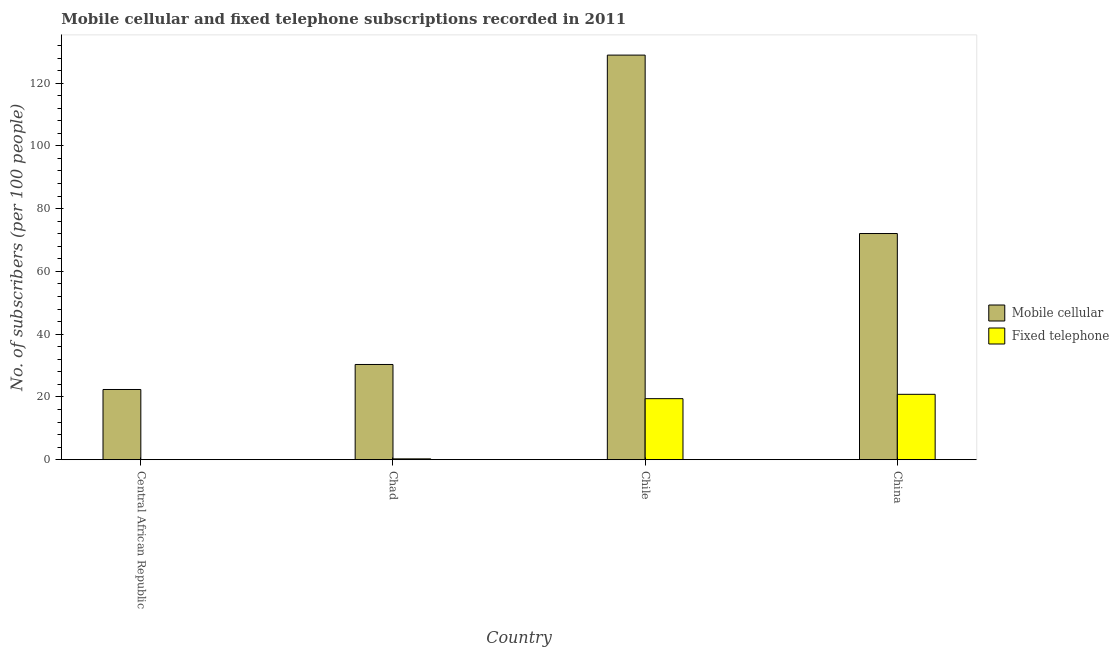Are the number of bars on each tick of the X-axis equal?
Offer a very short reply. Yes. In how many cases, is the number of bars for a given country not equal to the number of legend labels?
Make the answer very short. 0. What is the number of fixed telephone subscribers in Chad?
Make the answer very short. 0.26. Across all countries, what is the maximum number of mobile cellular subscribers?
Offer a very short reply. 128.93. Across all countries, what is the minimum number of fixed telephone subscribers?
Your response must be concise. 0.02. In which country was the number of fixed telephone subscribers minimum?
Your response must be concise. Central African Republic. What is the total number of fixed telephone subscribers in the graph?
Your response must be concise. 40.57. What is the difference between the number of mobile cellular subscribers in Central African Republic and that in China?
Provide a succinct answer. -49.7. What is the difference between the number of fixed telephone subscribers in China and the number of mobile cellular subscribers in Chad?
Offer a terse response. -9.51. What is the average number of fixed telephone subscribers per country?
Your answer should be compact. 10.14. What is the difference between the number of mobile cellular subscribers and number of fixed telephone subscribers in Chad?
Your answer should be compact. 30.08. What is the ratio of the number of fixed telephone subscribers in Central African Republic to that in Chile?
Provide a succinct answer. 0. Is the difference between the number of mobile cellular subscribers in Chad and Chile greater than the difference between the number of fixed telephone subscribers in Chad and Chile?
Make the answer very short. No. What is the difference between the highest and the second highest number of mobile cellular subscribers?
Provide a succinct answer. 56.86. What is the difference between the highest and the lowest number of mobile cellular subscribers?
Your response must be concise. 106.56. In how many countries, is the number of fixed telephone subscribers greater than the average number of fixed telephone subscribers taken over all countries?
Offer a very short reply. 2. What does the 2nd bar from the left in Chad represents?
Make the answer very short. Fixed telephone. What does the 2nd bar from the right in Chad represents?
Your answer should be compact. Mobile cellular. How many countries are there in the graph?
Provide a succinct answer. 4. What is the difference between two consecutive major ticks on the Y-axis?
Provide a succinct answer. 20. Are the values on the major ticks of Y-axis written in scientific E-notation?
Offer a terse response. No. How many legend labels are there?
Your response must be concise. 2. What is the title of the graph?
Ensure brevity in your answer.  Mobile cellular and fixed telephone subscriptions recorded in 2011. Does "Number of departures" appear as one of the legend labels in the graph?
Offer a terse response. No. What is the label or title of the X-axis?
Your answer should be compact. Country. What is the label or title of the Y-axis?
Provide a short and direct response. No. of subscribers (per 100 people). What is the No. of subscribers (per 100 people) in Mobile cellular in Central African Republic?
Keep it short and to the point. 22.37. What is the No. of subscribers (per 100 people) of Fixed telephone in Central African Republic?
Offer a very short reply. 0.02. What is the No. of subscribers (per 100 people) of Mobile cellular in Chad?
Provide a short and direct response. 30.34. What is the No. of subscribers (per 100 people) in Fixed telephone in Chad?
Your response must be concise. 0.26. What is the No. of subscribers (per 100 people) in Mobile cellular in Chile?
Offer a very short reply. 128.93. What is the No. of subscribers (per 100 people) of Fixed telephone in Chile?
Keep it short and to the point. 19.45. What is the No. of subscribers (per 100 people) of Mobile cellular in China?
Ensure brevity in your answer.  72.07. What is the No. of subscribers (per 100 people) of Fixed telephone in China?
Provide a succinct answer. 20.84. Across all countries, what is the maximum No. of subscribers (per 100 people) in Mobile cellular?
Provide a short and direct response. 128.93. Across all countries, what is the maximum No. of subscribers (per 100 people) of Fixed telephone?
Offer a terse response. 20.84. Across all countries, what is the minimum No. of subscribers (per 100 people) of Mobile cellular?
Give a very brief answer. 22.37. Across all countries, what is the minimum No. of subscribers (per 100 people) of Fixed telephone?
Make the answer very short. 0.02. What is the total No. of subscribers (per 100 people) in Mobile cellular in the graph?
Make the answer very short. 253.71. What is the total No. of subscribers (per 100 people) in Fixed telephone in the graph?
Keep it short and to the point. 40.57. What is the difference between the No. of subscribers (per 100 people) of Mobile cellular in Central African Republic and that in Chad?
Offer a terse response. -7.97. What is the difference between the No. of subscribers (per 100 people) of Fixed telephone in Central African Republic and that in Chad?
Provide a succinct answer. -0.25. What is the difference between the No. of subscribers (per 100 people) in Mobile cellular in Central African Republic and that in Chile?
Offer a terse response. -106.56. What is the difference between the No. of subscribers (per 100 people) in Fixed telephone in Central African Republic and that in Chile?
Give a very brief answer. -19.43. What is the difference between the No. of subscribers (per 100 people) in Mobile cellular in Central African Republic and that in China?
Your response must be concise. -49.7. What is the difference between the No. of subscribers (per 100 people) of Fixed telephone in Central African Republic and that in China?
Your response must be concise. -20.82. What is the difference between the No. of subscribers (per 100 people) in Mobile cellular in Chad and that in Chile?
Your response must be concise. -98.58. What is the difference between the No. of subscribers (per 100 people) of Fixed telephone in Chad and that in Chile?
Give a very brief answer. -19.19. What is the difference between the No. of subscribers (per 100 people) in Mobile cellular in Chad and that in China?
Provide a short and direct response. -41.73. What is the difference between the No. of subscribers (per 100 people) of Fixed telephone in Chad and that in China?
Offer a very short reply. -20.57. What is the difference between the No. of subscribers (per 100 people) in Mobile cellular in Chile and that in China?
Your answer should be compact. 56.86. What is the difference between the No. of subscribers (per 100 people) of Fixed telephone in Chile and that in China?
Give a very brief answer. -1.39. What is the difference between the No. of subscribers (per 100 people) in Mobile cellular in Central African Republic and the No. of subscribers (per 100 people) in Fixed telephone in Chad?
Your answer should be very brief. 22.11. What is the difference between the No. of subscribers (per 100 people) in Mobile cellular in Central African Republic and the No. of subscribers (per 100 people) in Fixed telephone in Chile?
Your answer should be very brief. 2.92. What is the difference between the No. of subscribers (per 100 people) in Mobile cellular in Central African Republic and the No. of subscribers (per 100 people) in Fixed telephone in China?
Offer a very short reply. 1.54. What is the difference between the No. of subscribers (per 100 people) of Mobile cellular in Chad and the No. of subscribers (per 100 people) of Fixed telephone in Chile?
Your answer should be compact. 10.9. What is the difference between the No. of subscribers (per 100 people) of Mobile cellular in Chad and the No. of subscribers (per 100 people) of Fixed telephone in China?
Make the answer very short. 9.51. What is the difference between the No. of subscribers (per 100 people) in Mobile cellular in Chile and the No. of subscribers (per 100 people) in Fixed telephone in China?
Ensure brevity in your answer.  108.09. What is the average No. of subscribers (per 100 people) of Mobile cellular per country?
Your answer should be compact. 63.43. What is the average No. of subscribers (per 100 people) of Fixed telephone per country?
Give a very brief answer. 10.14. What is the difference between the No. of subscribers (per 100 people) of Mobile cellular and No. of subscribers (per 100 people) of Fixed telephone in Central African Republic?
Offer a terse response. 22.35. What is the difference between the No. of subscribers (per 100 people) of Mobile cellular and No. of subscribers (per 100 people) of Fixed telephone in Chad?
Ensure brevity in your answer.  30.08. What is the difference between the No. of subscribers (per 100 people) in Mobile cellular and No. of subscribers (per 100 people) in Fixed telephone in Chile?
Give a very brief answer. 109.48. What is the difference between the No. of subscribers (per 100 people) in Mobile cellular and No. of subscribers (per 100 people) in Fixed telephone in China?
Give a very brief answer. 51.24. What is the ratio of the No. of subscribers (per 100 people) of Mobile cellular in Central African Republic to that in Chad?
Your answer should be compact. 0.74. What is the ratio of the No. of subscribers (per 100 people) of Fixed telephone in Central African Republic to that in Chad?
Keep it short and to the point. 0.07. What is the ratio of the No. of subscribers (per 100 people) of Mobile cellular in Central African Republic to that in Chile?
Your answer should be compact. 0.17. What is the ratio of the No. of subscribers (per 100 people) in Fixed telephone in Central African Republic to that in Chile?
Provide a short and direct response. 0. What is the ratio of the No. of subscribers (per 100 people) in Mobile cellular in Central African Republic to that in China?
Offer a very short reply. 0.31. What is the ratio of the No. of subscribers (per 100 people) in Fixed telephone in Central African Republic to that in China?
Your response must be concise. 0. What is the ratio of the No. of subscribers (per 100 people) of Mobile cellular in Chad to that in Chile?
Your response must be concise. 0.24. What is the ratio of the No. of subscribers (per 100 people) of Fixed telephone in Chad to that in Chile?
Give a very brief answer. 0.01. What is the ratio of the No. of subscribers (per 100 people) of Mobile cellular in Chad to that in China?
Make the answer very short. 0.42. What is the ratio of the No. of subscribers (per 100 people) in Fixed telephone in Chad to that in China?
Provide a succinct answer. 0.01. What is the ratio of the No. of subscribers (per 100 people) in Mobile cellular in Chile to that in China?
Provide a short and direct response. 1.79. What is the ratio of the No. of subscribers (per 100 people) of Fixed telephone in Chile to that in China?
Your answer should be very brief. 0.93. What is the difference between the highest and the second highest No. of subscribers (per 100 people) of Mobile cellular?
Provide a short and direct response. 56.86. What is the difference between the highest and the second highest No. of subscribers (per 100 people) of Fixed telephone?
Your answer should be very brief. 1.39. What is the difference between the highest and the lowest No. of subscribers (per 100 people) of Mobile cellular?
Offer a very short reply. 106.56. What is the difference between the highest and the lowest No. of subscribers (per 100 people) in Fixed telephone?
Keep it short and to the point. 20.82. 